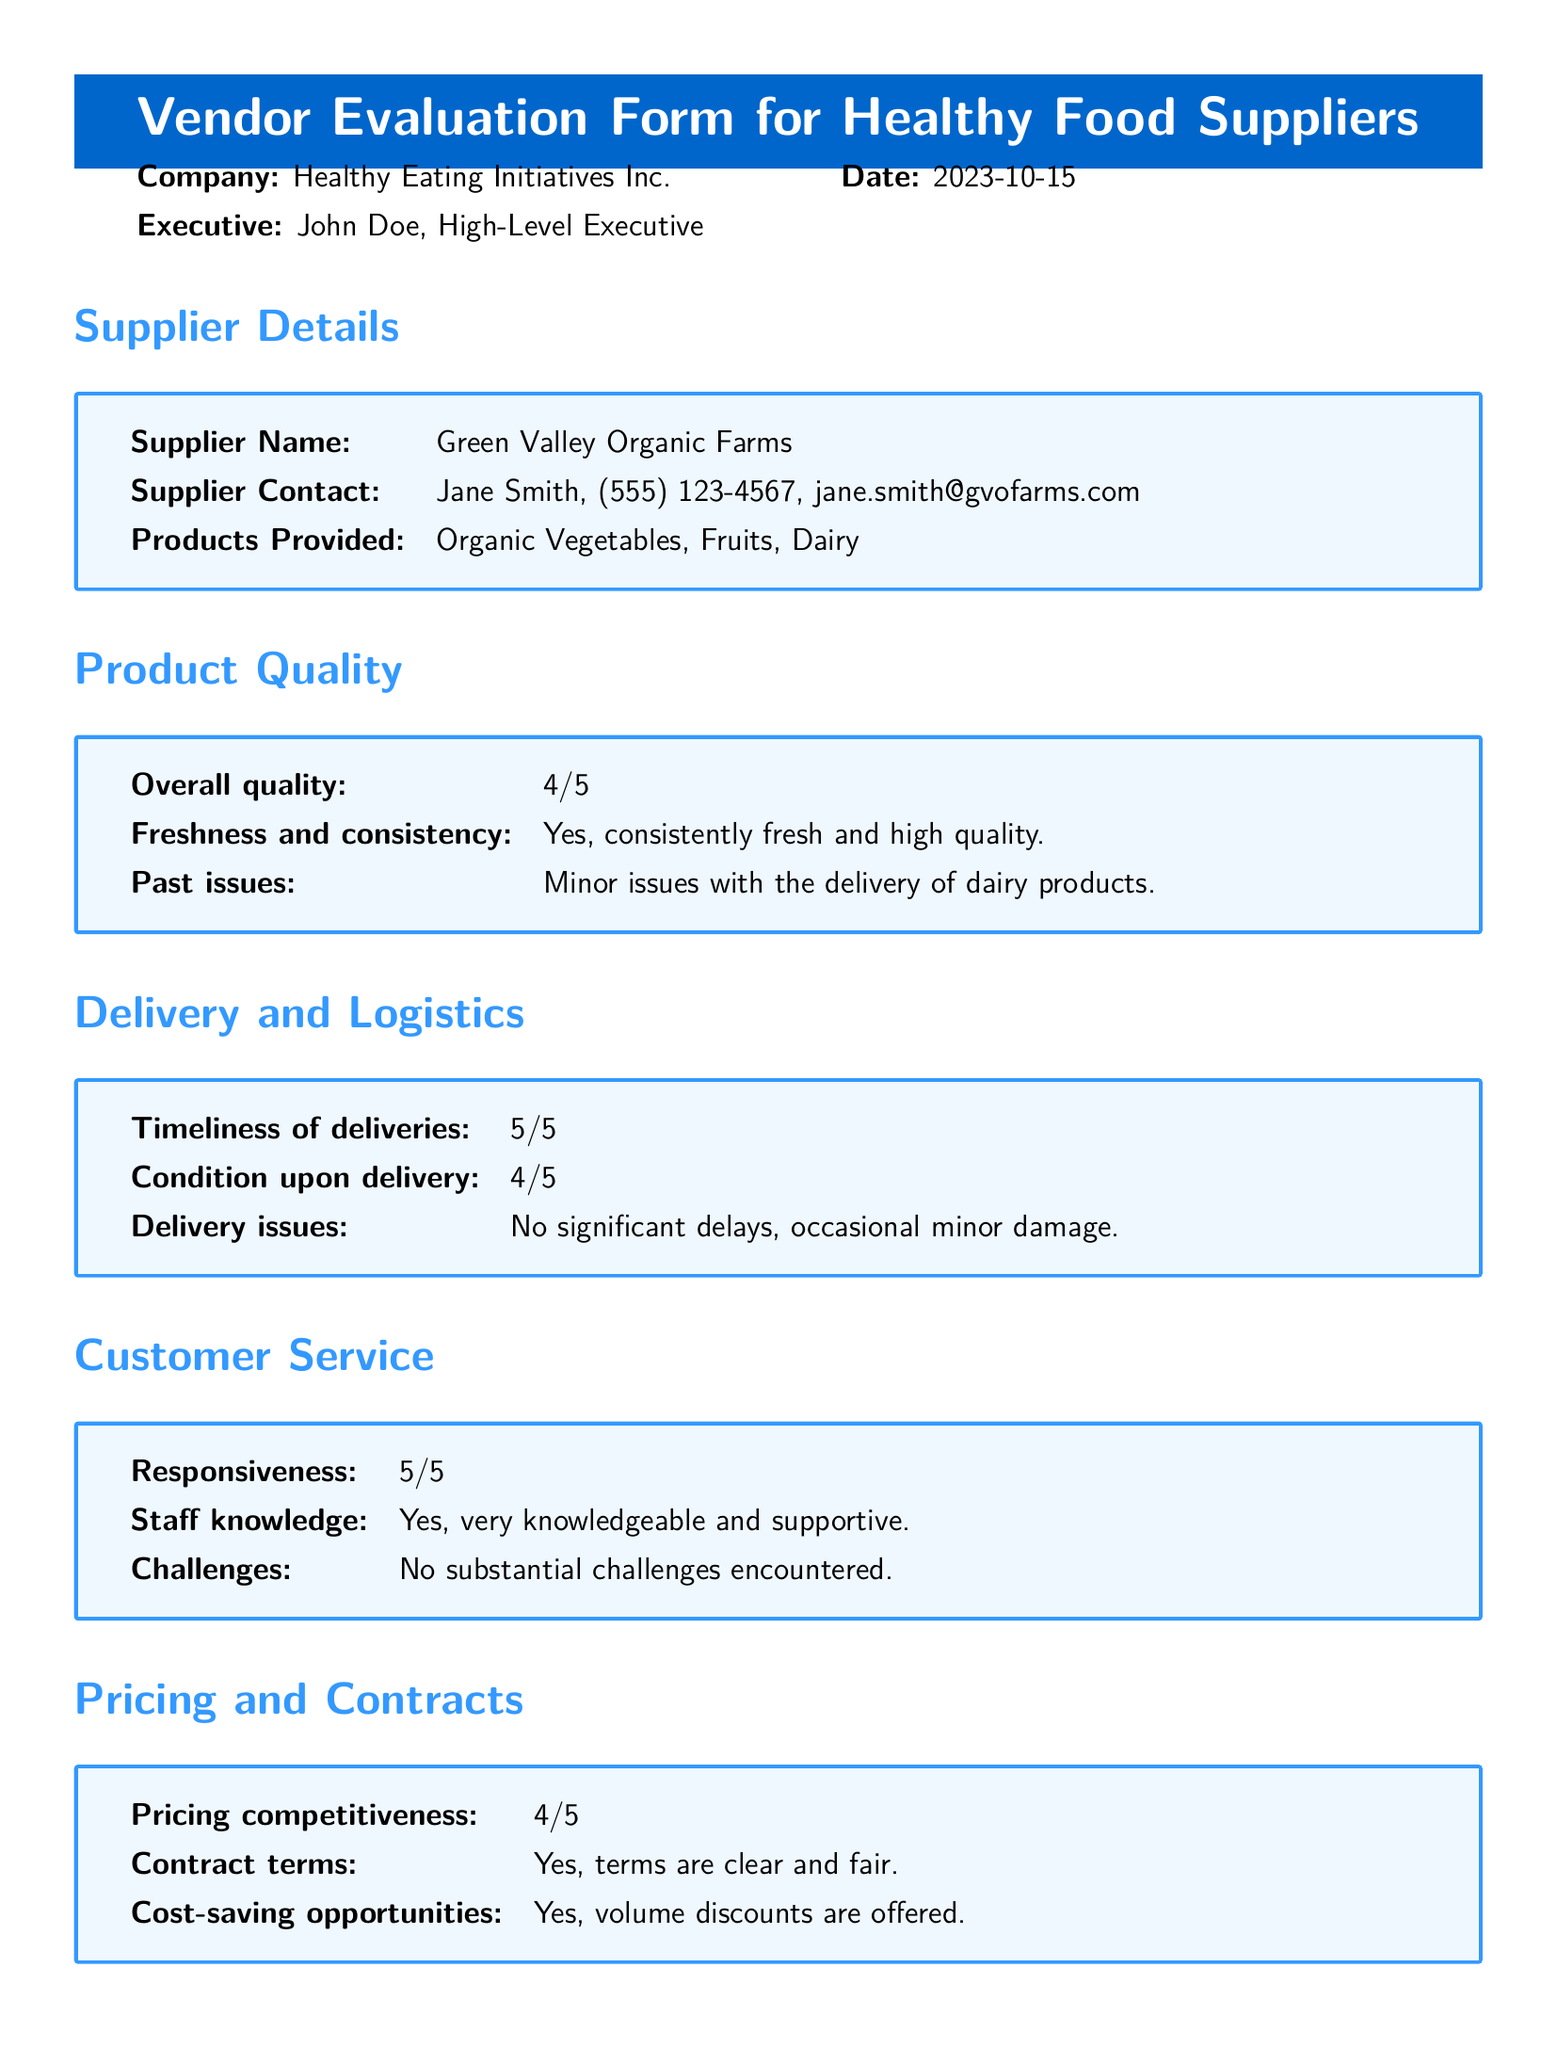What is the supplier's name? The supplier's name is listed under Supplier Details in the document.
Answer: Green Valley Organic Farms What is the overall quality rating? The overall quality rating is provided in the Product Quality section.
Answer: 4/5 Who is the supplier contact? The supplier contact information is provided in the Supplier Details section of the document.
Answer: Jane Smith What is the timeliness of deliveries rating? The rating for timeliness of deliveries can be found in the Delivery and Logistics section.
Answer: 5/5 What area needs improvement according to the document? The area needing improvement is specified in the Improvement Suggestions section.
Answer: Enhance packaging What is the date of the evaluation? The date of the evaluation is noted in the header of the document.
Answer: 2023-10-15 What is the pricing competitiveness rating? The pricing competitiveness rating is found in the Pricing and Contracts section.
Answer: 4/5 Is there a suggestion to expand the product variety? The suggestion regarding product variety can be found in the Improvement Suggestions section.
Answer: Yes What did the evaluation note about past issues? Past issues related to product quality are mentioned in the Product Quality section.
Answer: Minor issues with the delivery of dairy products 